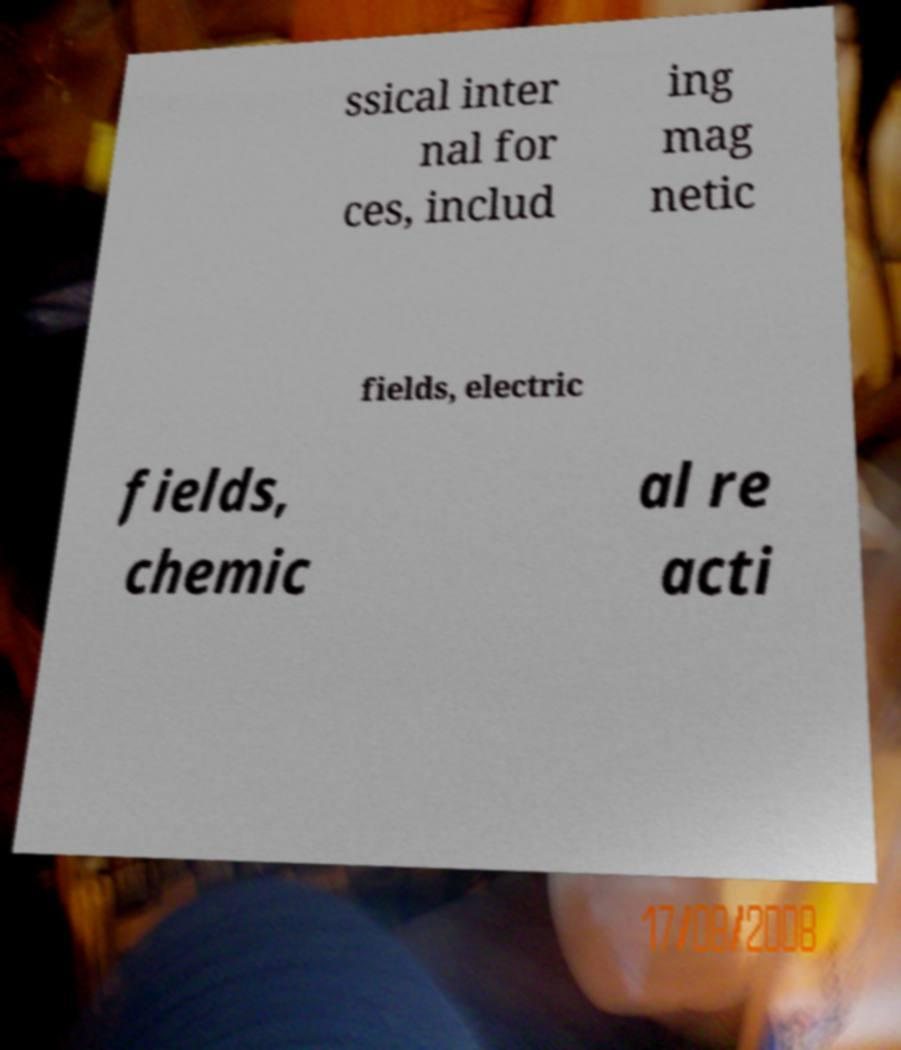Could you assist in decoding the text presented in this image and type it out clearly? ssical inter nal for ces, includ ing mag netic fields, electric fields, chemic al re acti 